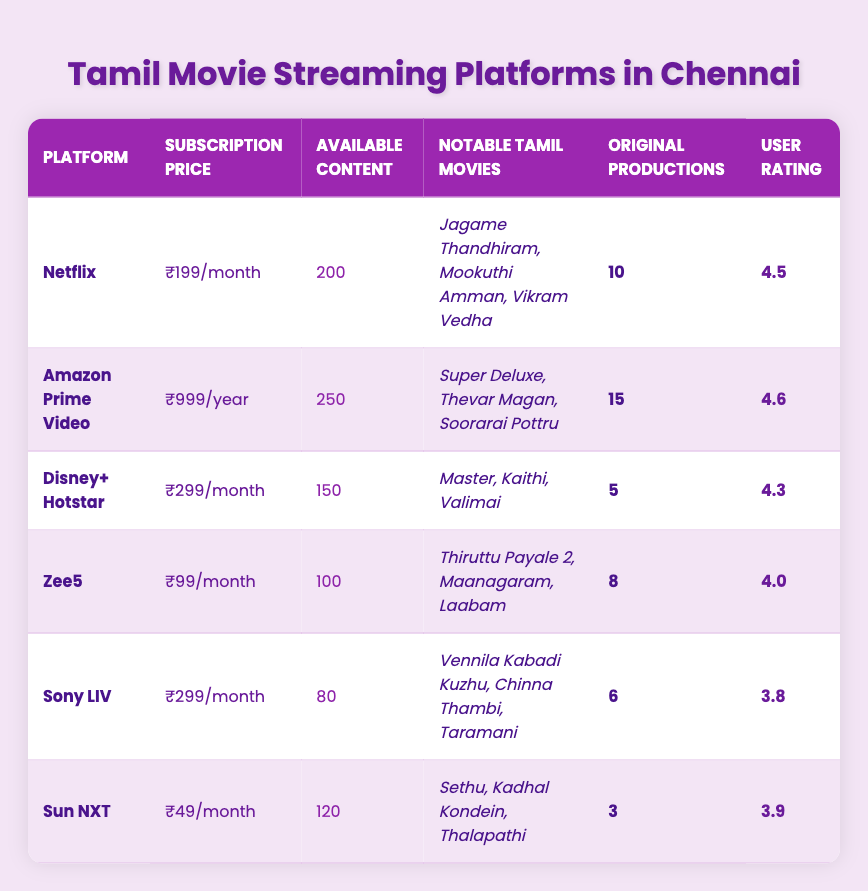What is the subscription price for Amazon Prime Video? The table lists the subscription price for Amazon Prime Video under the respective column, which shows ₹999/year.
Answer: ₹999/year Which platform has the highest user rating? Looking at the User Rating column, Amazon Prime Video has the highest rating of 4.6 compared to other platforms.
Answer: Amazon Prime Video How many original productions does Netflix have? The table specifies that Netflix has 10 original productions listed under the Original Productions column.
Answer: 10 What is the total number of available content across all platforms? By adding the available content: 200 (Netflix) + 250 (Amazon Prime Video) + 150 (Disney+ Hotstar) + 100 (Zee5) + 80 (Sony LIV) + 120 (Sun NXT) = 1,000.
Answer: 1000 How much cheaper is Sun NXT compared to Disney+ Hotstar? The subscription price for Sun NXT is ₹49/month and for Disney+ Hotstar is ₹299/month. The difference is ₹299 - ₹49 = ₹250.
Answer: ₹250 Does Zee5 offer more notable Tamil movies than Sony LIV? Zee5 has 3 notable Tamil movies while Sony LIV has 3 as well. Comparing the two shows they have the same number of notable films.
Answer: No Which platform has the least amount of available content? The Available Content column shows that Sony LIV has only 80 titles, which is the least compared to other platforms.
Answer: Sony LIV How many original productions does Amazon Prime Video have in comparison to Sun NXT? Amazon Prime Video has 15 original productions and Sun NXT has 3. The difference is 15 - 3 = 12 more original productions for Amazon Prime Video.
Answer: 12 Which platform has notable Tamil movies such as "Vikram Vedha"? The table indicates that "Vikram Vedha" is listed under the notable Tamil movies for Netflix.
Answer: Netflix If you want to stream Tamil movies for less than ₹100/month, which platform can you choose? The only platform with a subscription price less than ₹100/month listed is Sun NXT, which costs ₹49/month.
Answer: Sun NXT 